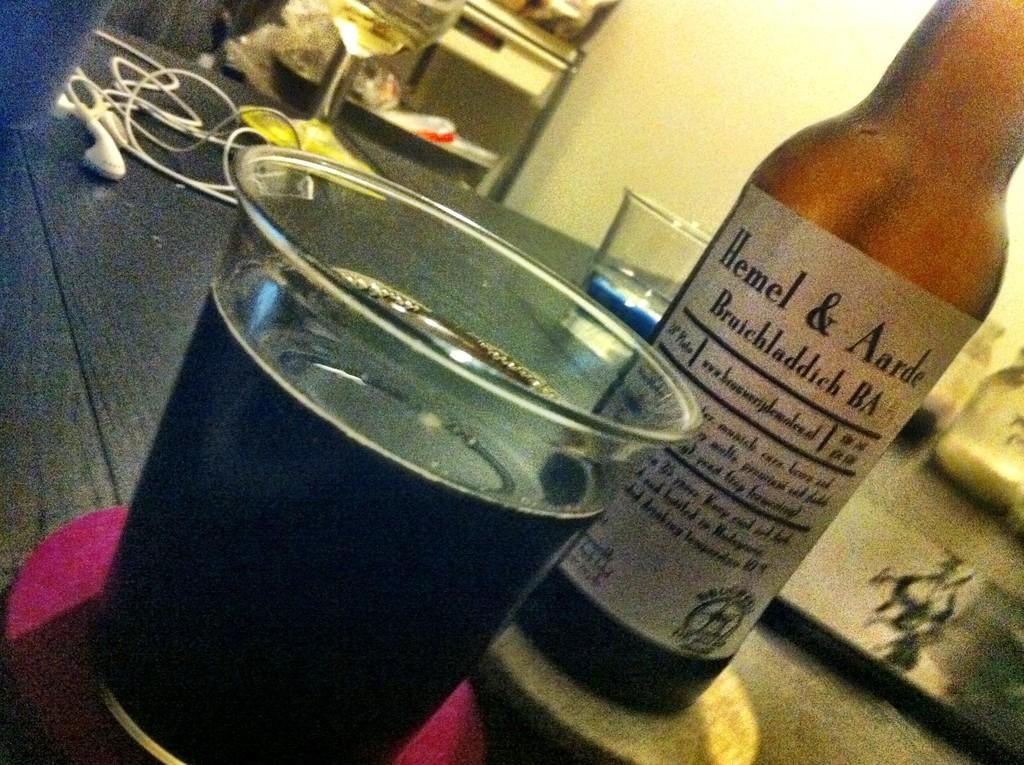What initials are on the second line?
Provide a succinct answer. Ba. 